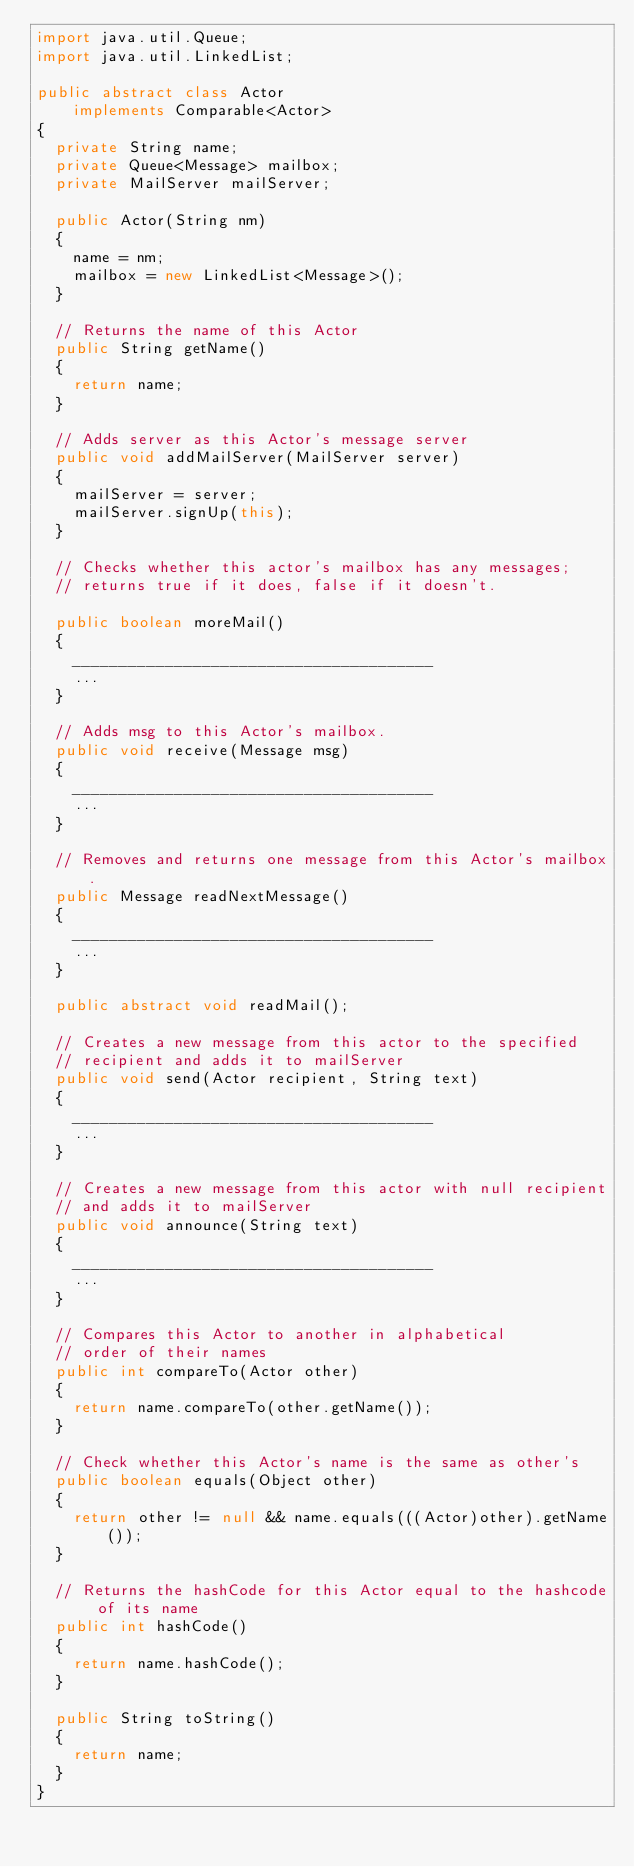<code> <loc_0><loc_0><loc_500><loc_500><_Java_>import java.util.Queue;
import java.util.LinkedList;

public abstract class Actor
    implements Comparable<Actor>
{
  private String name;
  private Queue<Message> mailbox;
  private MailServer mailServer;

  public Actor(String nm)
  {
    name = nm;
    mailbox = new LinkedList<Message>();
  }

  // Returns the name of this Actor
  public String getName()
  {
    return name;
  }

  // Adds server as this Actor's message server
  public void addMailServer(MailServer server)
  {
    mailServer = server;
    mailServer.signUp(this);
  }

  // Checks whether this actor's mailbox has any messages;
  // returns true if it does, false if it doesn't.

  public boolean moreMail()
  {
    _______________________________________
    ...
  }

  // Adds msg to this Actor's mailbox.
  public void receive(Message msg)
  {
    _______________________________________
    ...
  }

  // Removes and returns one message from this Actor's mailbox.
  public Message readNextMessage()
  {
    _______________________________________
    ...
  }

  public abstract void readMail();

  // Creates a new message from this actor to the specified
  // recipient and adds it to mailServer
  public void send(Actor recipient, String text)
  {
    _______________________________________
    ...
  }

  // Creates a new message from this actor with null recipient
  // and adds it to mailServer
  public void announce(String text)
  {
    _______________________________________
    ...
  }

  // Compares this Actor to another in alphabetical
  // order of their names
  public int compareTo(Actor other)
  {
    return name.compareTo(other.getName());
  }

  // Check whether this Actor's name is the same as other's
  public boolean equals(Object other)
  {
    return other != null && name.equals(((Actor)other).getName());
  }

  // Returns the hashCode for this Actor equal to the hashcode of its name
  public int hashCode()
  {
    return name.hashCode();
  }

  public String toString()
  {
    return name;
  }
}
</code> 